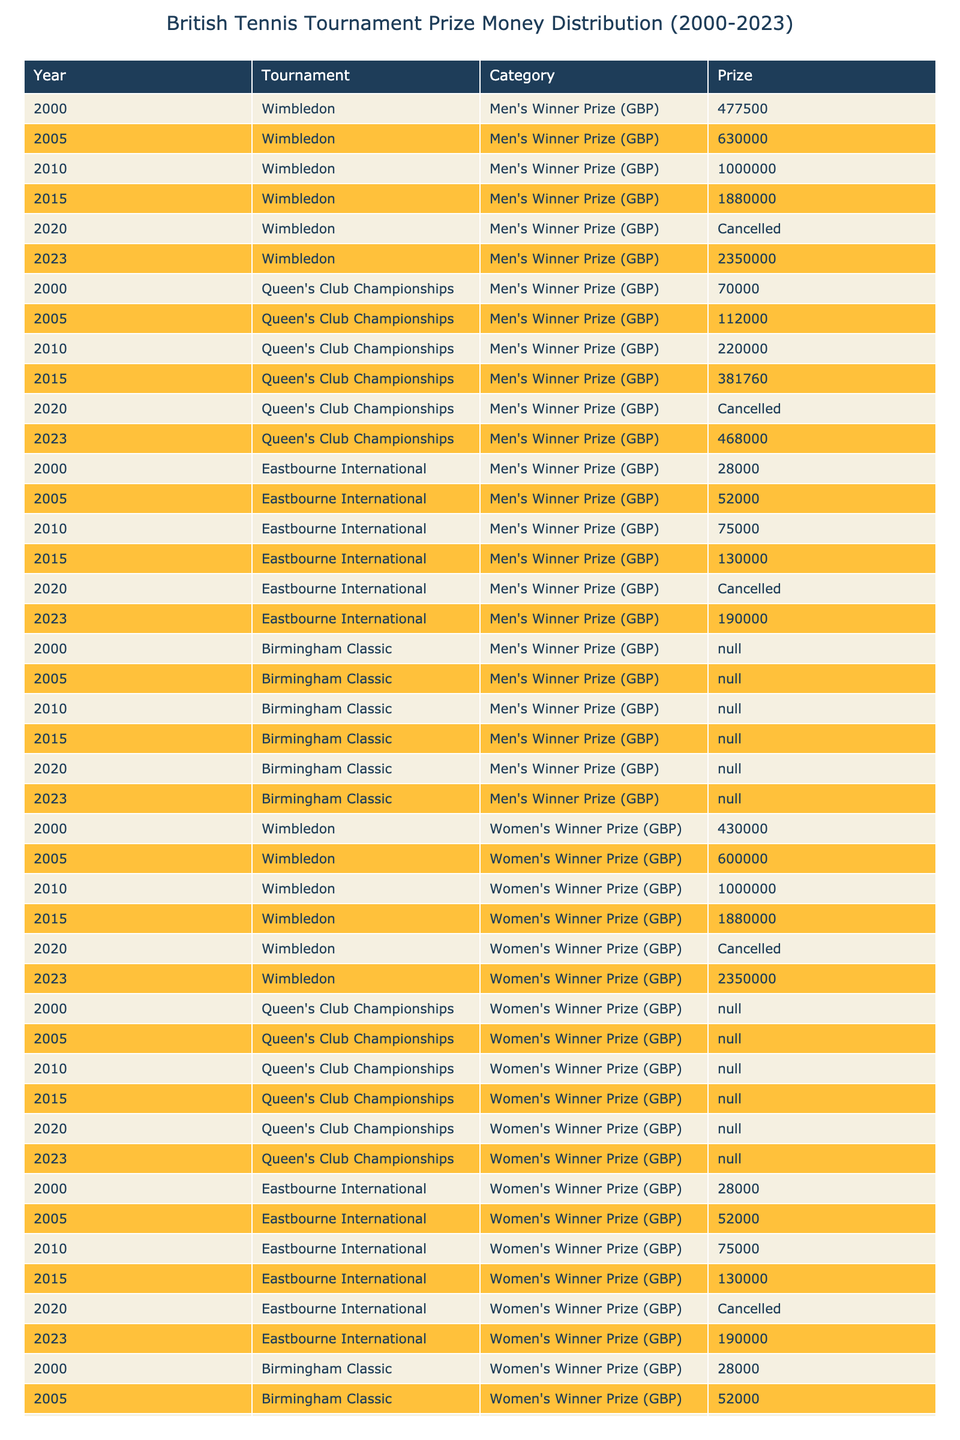What was the prize for the men's winner at Wimbledon in 2015? Referring to the table, the prize for the men's winner at Wimbledon in 2015 is listed as £1,880,000.
Answer: £1,880,000 What is the total prize money for women's winners at Queen's Club Championships from 2000 to 2023? Looking at the table, the women's winner prizes for Queen's Club Championships are £N/A (2000), £N/A (2005), £N/A (2010), £N/A (2015), £N/A (2020), and £468,000 (2023). Since most data points are N/A, only the 2023 value counts, totaling £468,000.
Answer: £468,000 Did the prize money for men's and women's winners at Wimbledon in 2010 differ? In 2010, the prize money for both the men's and women's winners at Wimbledon was the same, £1,000,000.
Answer: No Calculate the difference between the men's winner prize and the women's winner prize at Eastbourne International in 2023. The men's winner prize in 2023 at Eastbourne International is £190,000, and the women's winner prize is also £190,000. The difference is £190,000 - £190,000 = £0.
Answer: £0 What years had cancelled tournaments for the Eastbourne International, and how many total years were there? The table shows that the Eastbourne International was cancelled in 2020. Since the data spans from 2000 to 2023, the tournaments were held for 22 years total, indicating only one cancellation.
Answer: One year What is the average prize money for men's winners at Wimbledon from 2000 to 2023? Adding the values for men's winners: £477,500 (2000) + £630,000 (2005) + £1,000,000 (2010) + £1,880,000 (2015) + £0 (2020) + £2,350,000 (2023) = £6,937,500. There are five data points. Therefore, the average is £6,937,500 / 5 = £1,387,500.
Answer: £1,387,500 Which tournament had the highest prize for the women’s runner-up in 2023? The table records the women’s runner-up prize for Wimbledon as £1,175,000 and for Queen's Club Championships and Eastbourne International both as £N/A. Thus, the highest prize for the 2023 runner-up is £1,175,000, awarded at Wimbledon.
Answer: Wimbledon If we consider the overall prize distributions for men's and women's winners from 2000 to 2023, is there a consistency trend towards equal prizes? Review of data shows that Wimbledon maintained equal prizes in 2010 and 2015, but prior years had differences, and data for some years at other tournaments are not available. Thus, a clear trend towards equal prizes cannot be established.
Answer: No What was the total men's prize money awarded across all tournaments in 2010? Men's winner prizes awarded in 2010: £1,000,000 (Wimbledon) + £220,000 (Queen's Club Championships) + £75,000 (Eastbourne International) + £0 (Birmingham Classic) = £1,295,000. Therefore, total prize money for men's winners in 2010 is £1,295,000.
Answer: £1,295,000 